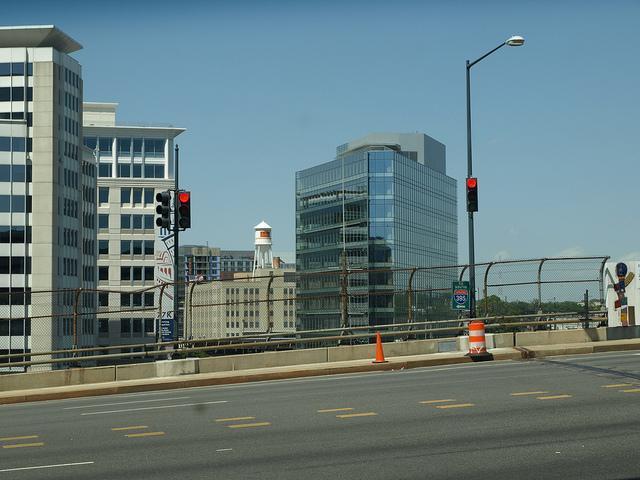How many orange cones are visible?
Give a very brief answer. 2. How many cones are there?
Give a very brief answer. 1. How many cars are there?
Give a very brief answer. 0. 